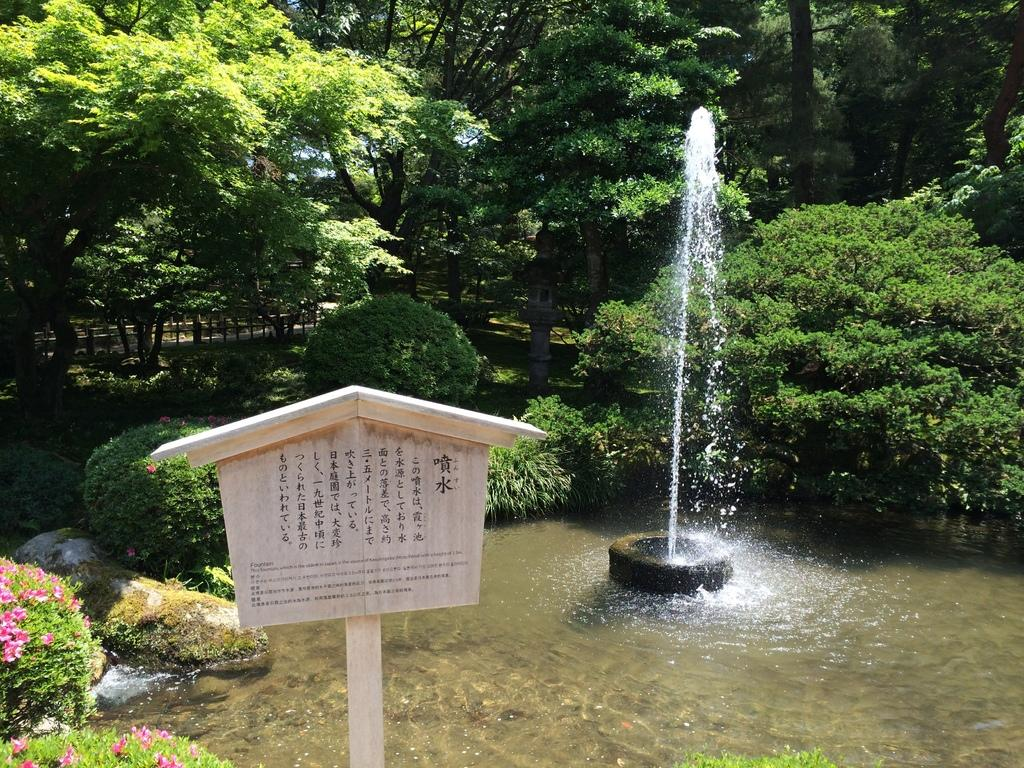What is located in the foreground of the image? There is signage in the foreground of the image. What can be seen in the background of the image? There is a fountain, plants, and trees in the background of the image. Where are the flowers located in the image? The flowers are in the left bottom corner of the image. How much money is being exchanged in the image? There is no indication of money or any exchange in the image. What type of liquid is coming out of the fountain in the image? The image does not provide enough detail to determine the type of liquid coming out of the fountain. Can you see a cat in the image? There is no cat present in the image. 